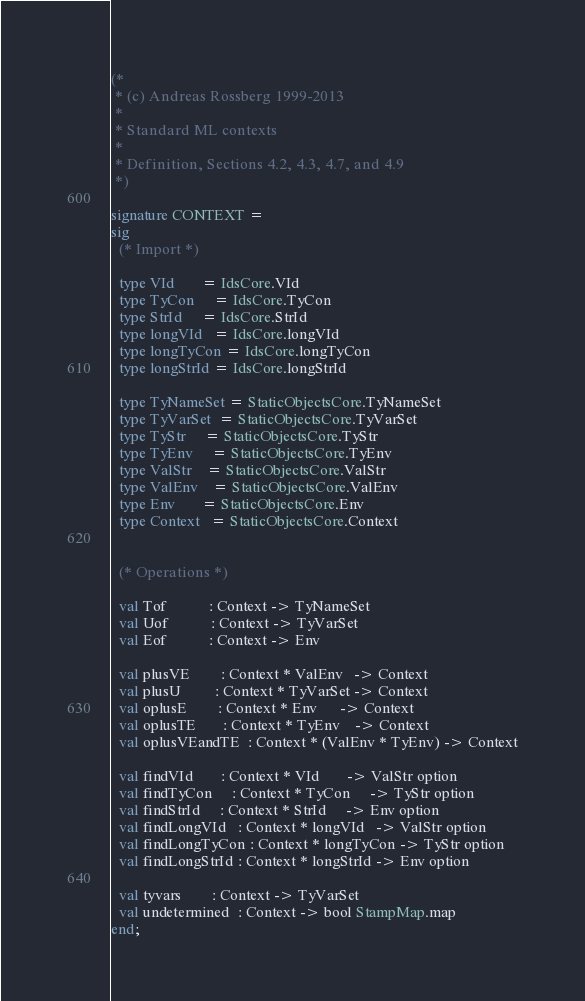<code> <loc_0><loc_0><loc_500><loc_500><_SML_>(*
 * (c) Andreas Rossberg 1999-2013
 *
 * Standard ML contexts
 *
 * Definition, Sections 4.2, 4.3, 4.7, and 4.9
 *)

signature CONTEXT =
sig
  (* Import *)

  type VId       = IdsCore.VId
  type TyCon     = IdsCore.TyCon
  type StrId     = IdsCore.StrId
  type longVId   = IdsCore.longVId
  type longTyCon = IdsCore.longTyCon
  type longStrId = IdsCore.longStrId

  type TyNameSet = StaticObjectsCore.TyNameSet
  type TyVarSet  = StaticObjectsCore.TyVarSet
  type TyStr     = StaticObjectsCore.TyStr
  type TyEnv     = StaticObjectsCore.TyEnv
  type ValStr    = StaticObjectsCore.ValStr
  type ValEnv    = StaticObjectsCore.ValEnv
  type Env       = StaticObjectsCore.Env
  type Context   = StaticObjectsCore.Context


  (* Operations *)

  val Tof           : Context -> TyNameSet
  val Uof           : Context -> TyVarSet
  val Eof           : Context -> Env

  val plusVE        : Context * ValEnv   -> Context
  val plusU         : Context * TyVarSet -> Context
  val oplusE        : Context * Env      -> Context
  val oplusTE       : Context * TyEnv    -> Context
  val oplusVEandTE  : Context * (ValEnv * TyEnv) -> Context

  val findVId       : Context * VId       -> ValStr option
  val findTyCon     : Context * TyCon     -> TyStr option
  val findStrId     : Context * StrId     -> Env option
  val findLongVId   : Context * longVId   -> ValStr option
  val findLongTyCon : Context * longTyCon -> TyStr option
  val findLongStrId : Context * longStrId -> Env option

  val tyvars        : Context -> TyVarSet
  val undetermined  : Context -> bool StampMap.map
end;
</code> 